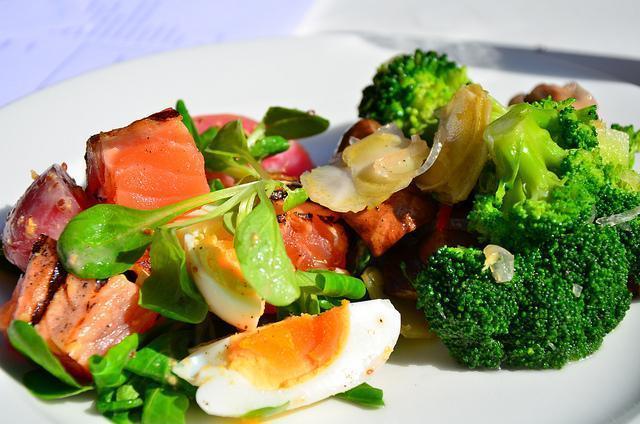How many broccolis can be seen?
Give a very brief answer. 2. How many people are wearing white shirts?
Give a very brief answer. 0. 